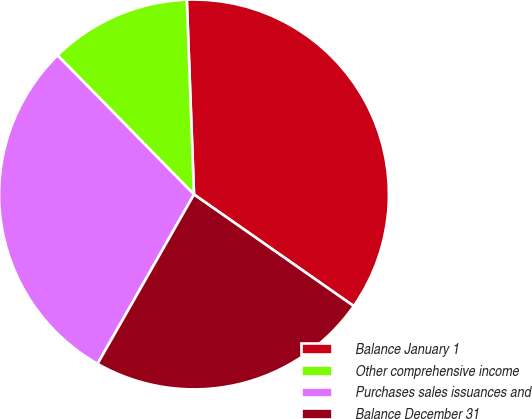Convert chart to OTSL. <chart><loc_0><loc_0><loc_500><loc_500><pie_chart><fcel>Balance January 1<fcel>Other comprehensive income<fcel>Purchases sales issuances and<fcel>Balance December 31<nl><fcel>35.29%<fcel>11.76%<fcel>29.41%<fcel>23.53%<nl></chart> 